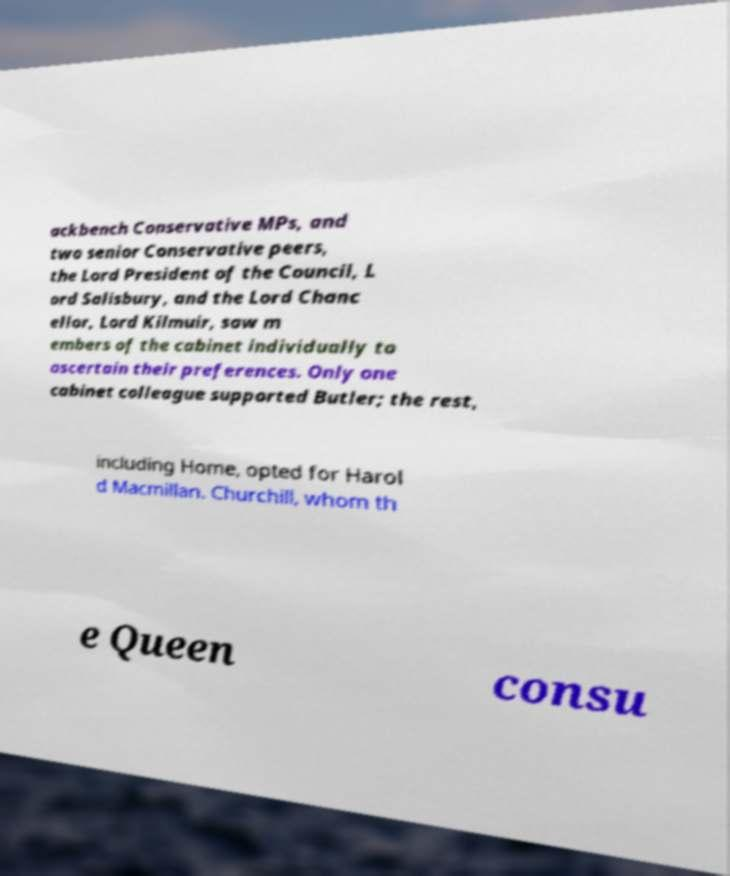Please identify and transcribe the text found in this image. ackbench Conservative MPs, and two senior Conservative peers, the Lord President of the Council, L ord Salisbury, and the Lord Chanc ellor, Lord Kilmuir, saw m embers of the cabinet individually to ascertain their preferences. Only one cabinet colleague supported Butler; the rest, including Home, opted for Harol d Macmillan. Churchill, whom th e Queen consu 